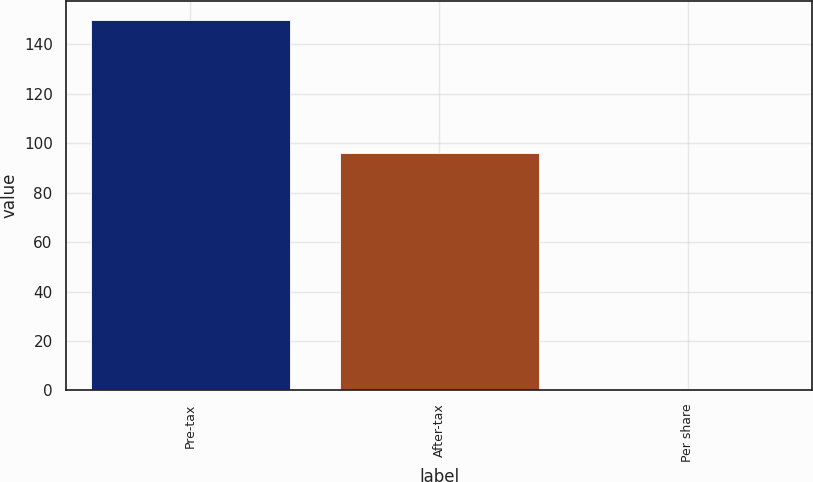<chart> <loc_0><loc_0><loc_500><loc_500><bar_chart><fcel>Pre-tax<fcel>After-tax<fcel>Per share<nl><fcel>150<fcel>96<fcel>0.06<nl></chart> 